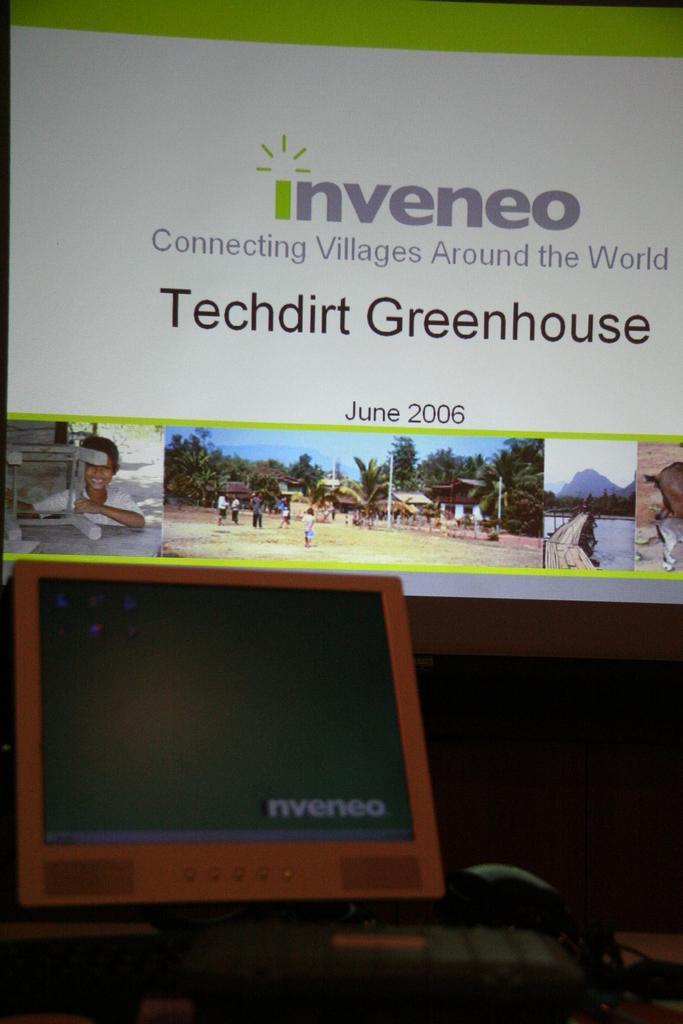Could you give a brief overview of what you see in this image? In this image we can see a monitor, keyboard and some wires on a table. On the backside we can see a display screen in which we can see some pictures and text on it. 